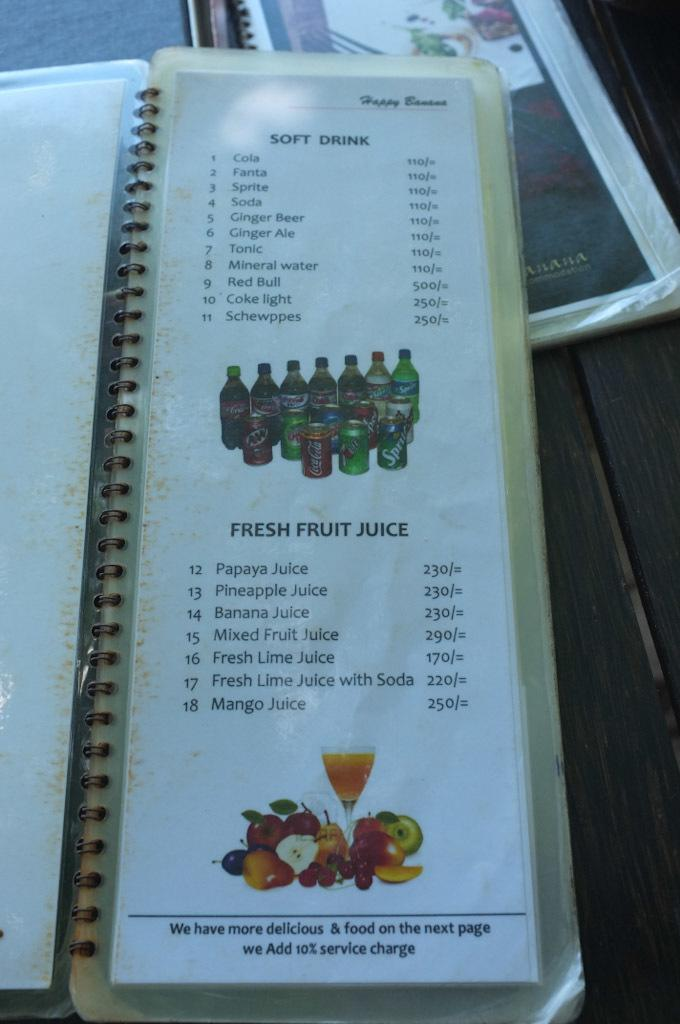What objects are present in the image related to food or dining? There are menu books in the image. What information can be found in the menu books? There is text visible in the menu books. What type of argument is taking place between the menu books in the image? There is no argument present in the image; it only features menu books with text. 